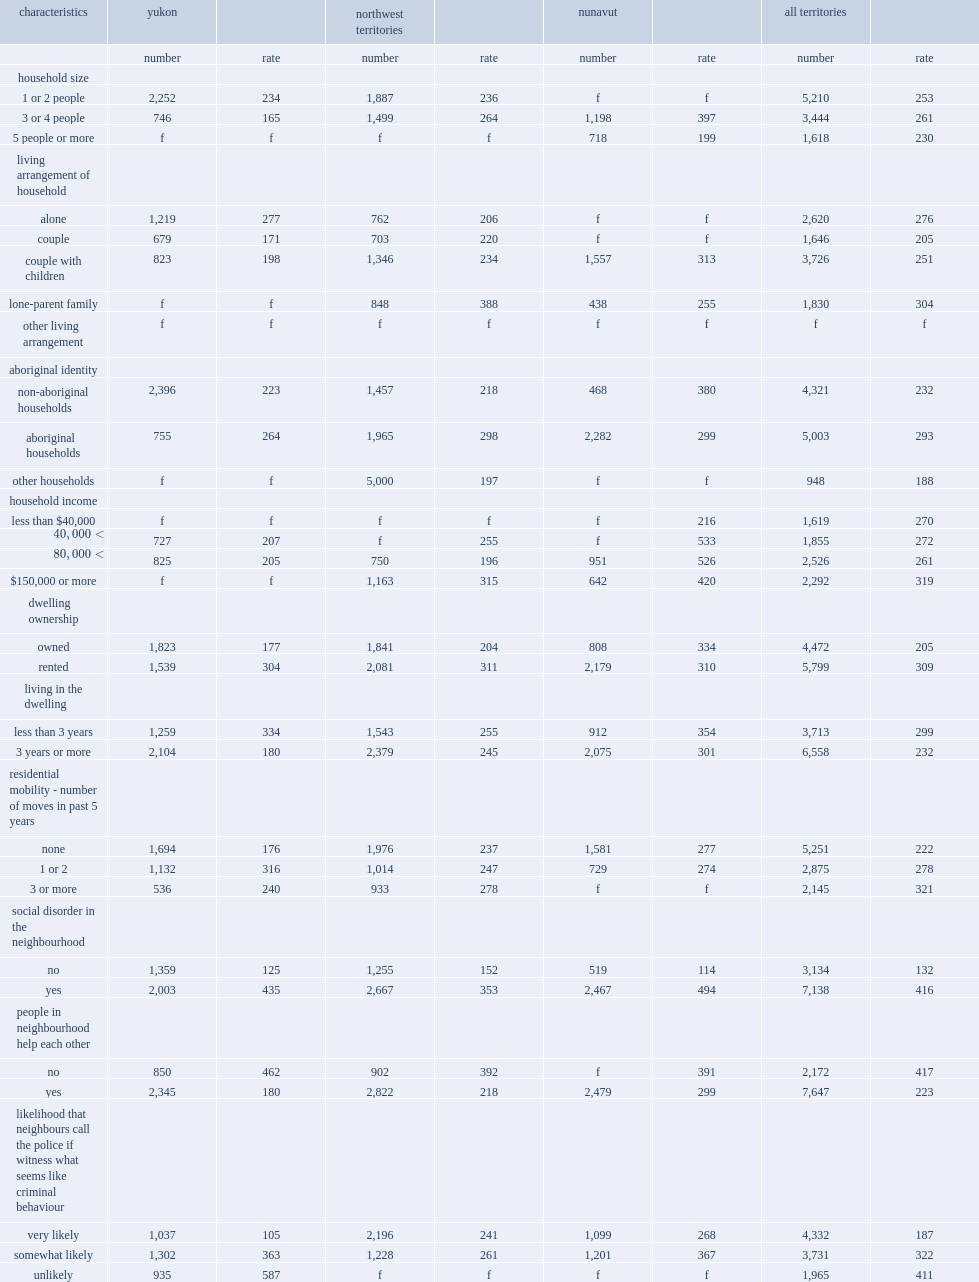What is the victimization rate in households located in neighbourhoods where people do not help each other is 417 per 1,000 households? 417.0. What is the victimization rate in households located in neighbourhoods where people help each other is 417 per 1,000 households? 223.0. What is the victimization rate among households located in an area where neighbours are unlikely to call the police if they witness a criminal act was 411e incidents per 1,000 households? 411.0. What is the victimization rate among households located in an area where neighbours are unlikely to call the police if they witness a criminal act was 411e incidents per 1,000 households? 416.0. What was the household victimization rate of tenant households? 309.0. What was the household victimization rate of owner households? 205.0. What was the household victimization rate of ouseholds that had occupied their dwelling for less than three years? 299.0. What was the household victimization rate of ouseholds that had occupied their dwelling for three years or more? 232.0. 